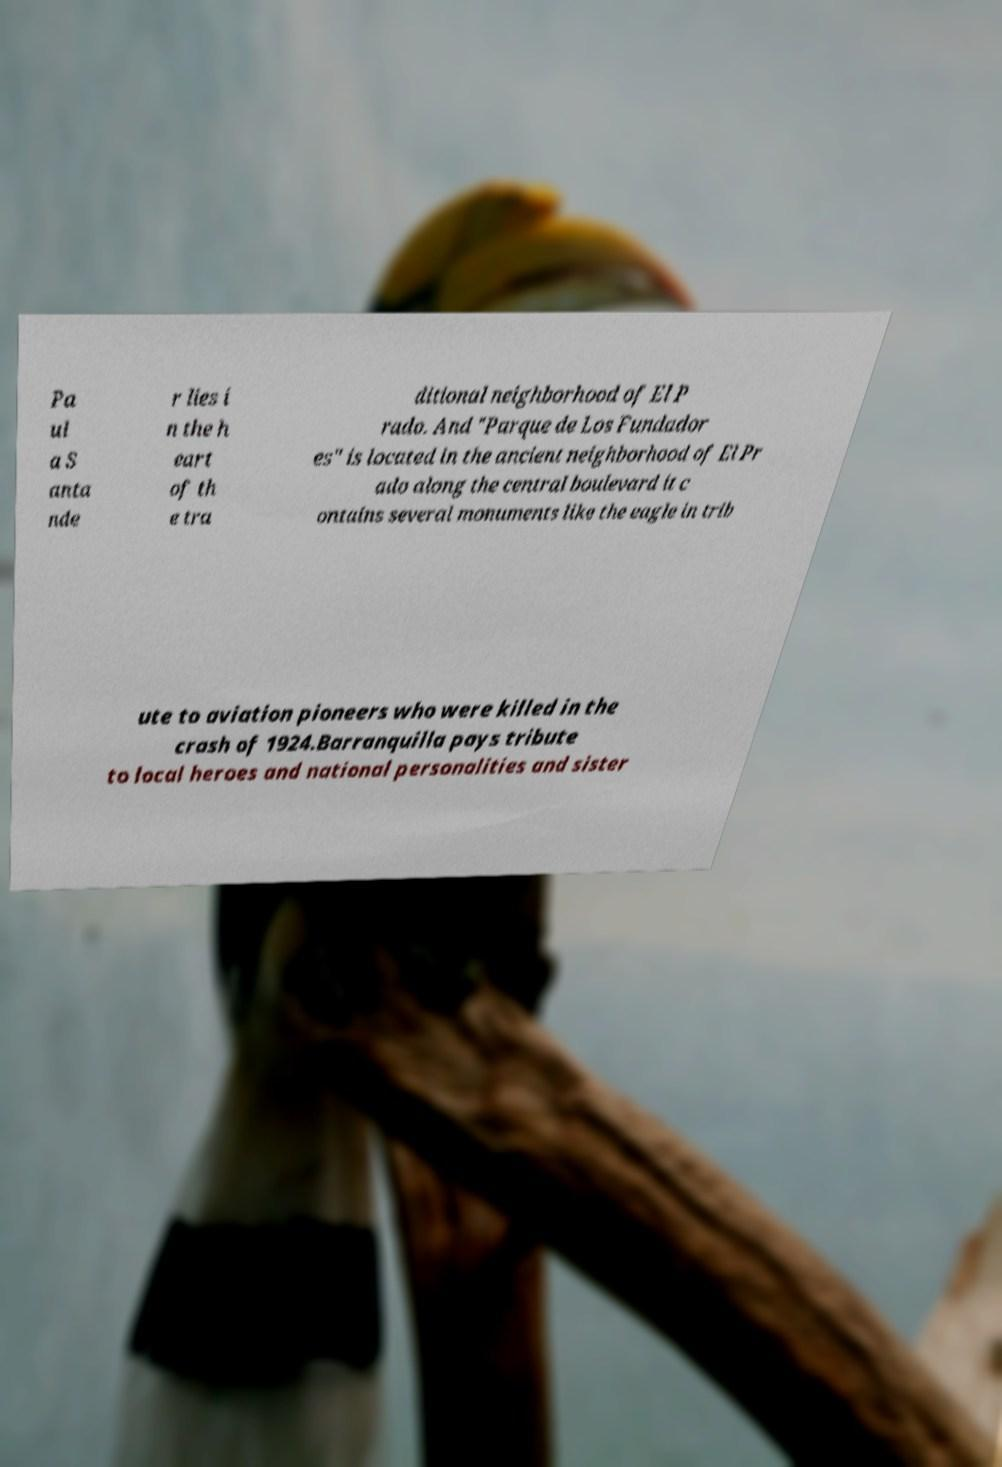What messages or text are displayed in this image? I need them in a readable, typed format. Pa ul a S anta nde r lies i n the h eart of th e tra ditional neighborhood of El P rado. And "Parque de Los Fundador es" is located in the ancient neighborhood of El Pr ado along the central boulevard it c ontains several monuments like the eagle in trib ute to aviation pioneers who were killed in the crash of 1924.Barranquilla pays tribute to local heroes and national personalities and sister 